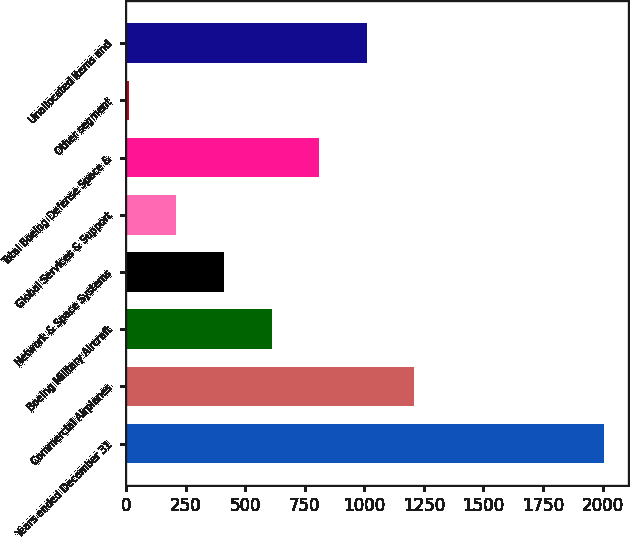Convert chart. <chart><loc_0><loc_0><loc_500><loc_500><bar_chart><fcel>Years ended December 31<fcel>Commercial Airplanes<fcel>Boeing Military Aircraft<fcel>Network & Space Systems<fcel>Global Services & Support<fcel>Total Boeing Defense Space &<fcel>Other segment<fcel>Unallocated items and<nl><fcel>2008<fcel>1209.6<fcel>610.8<fcel>411.2<fcel>211.6<fcel>810.4<fcel>12<fcel>1010<nl></chart> 